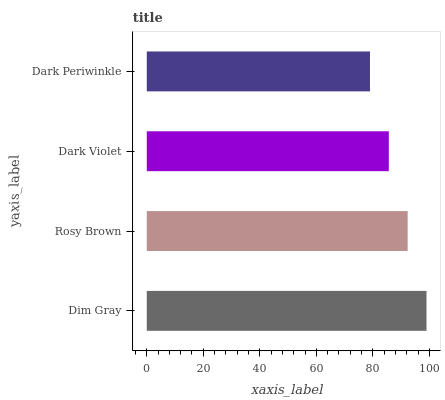Is Dark Periwinkle the minimum?
Answer yes or no. Yes. Is Dim Gray the maximum?
Answer yes or no. Yes. Is Rosy Brown the minimum?
Answer yes or no. No. Is Rosy Brown the maximum?
Answer yes or no. No. Is Dim Gray greater than Rosy Brown?
Answer yes or no. Yes. Is Rosy Brown less than Dim Gray?
Answer yes or no. Yes. Is Rosy Brown greater than Dim Gray?
Answer yes or no. No. Is Dim Gray less than Rosy Brown?
Answer yes or no. No. Is Rosy Brown the high median?
Answer yes or no. Yes. Is Dark Violet the low median?
Answer yes or no. Yes. Is Dim Gray the high median?
Answer yes or no. No. Is Dark Periwinkle the low median?
Answer yes or no. No. 